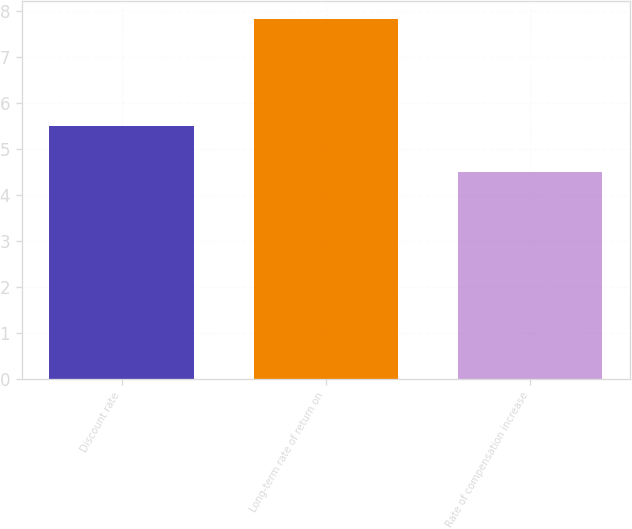Convert chart to OTSL. <chart><loc_0><loc_0><loc_500><loc_500><bar_chart><fcel>Discount rate<fcel>Long-term rate of return on<fcel>Rate of compensation increase<nl><fcel>5.5<fcel>7.83<fcel>4.5<nl></chart> 